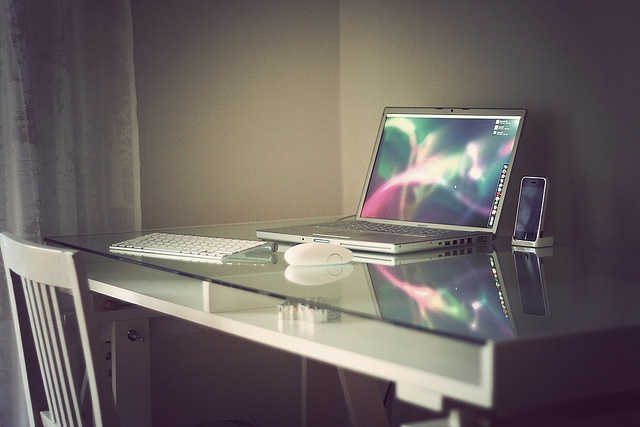Describe the objects in this image and their specific colors. I can see laptop in gray, beige, darkgray, and teal tones, chair in gray, black, and darkgray tones, keyboard in gray, ivory, darkgray, and lightgray tones, cell phone in gray, black, and purple tones, and mouse in gray, beige, tan, and darkgray tones in this image. 